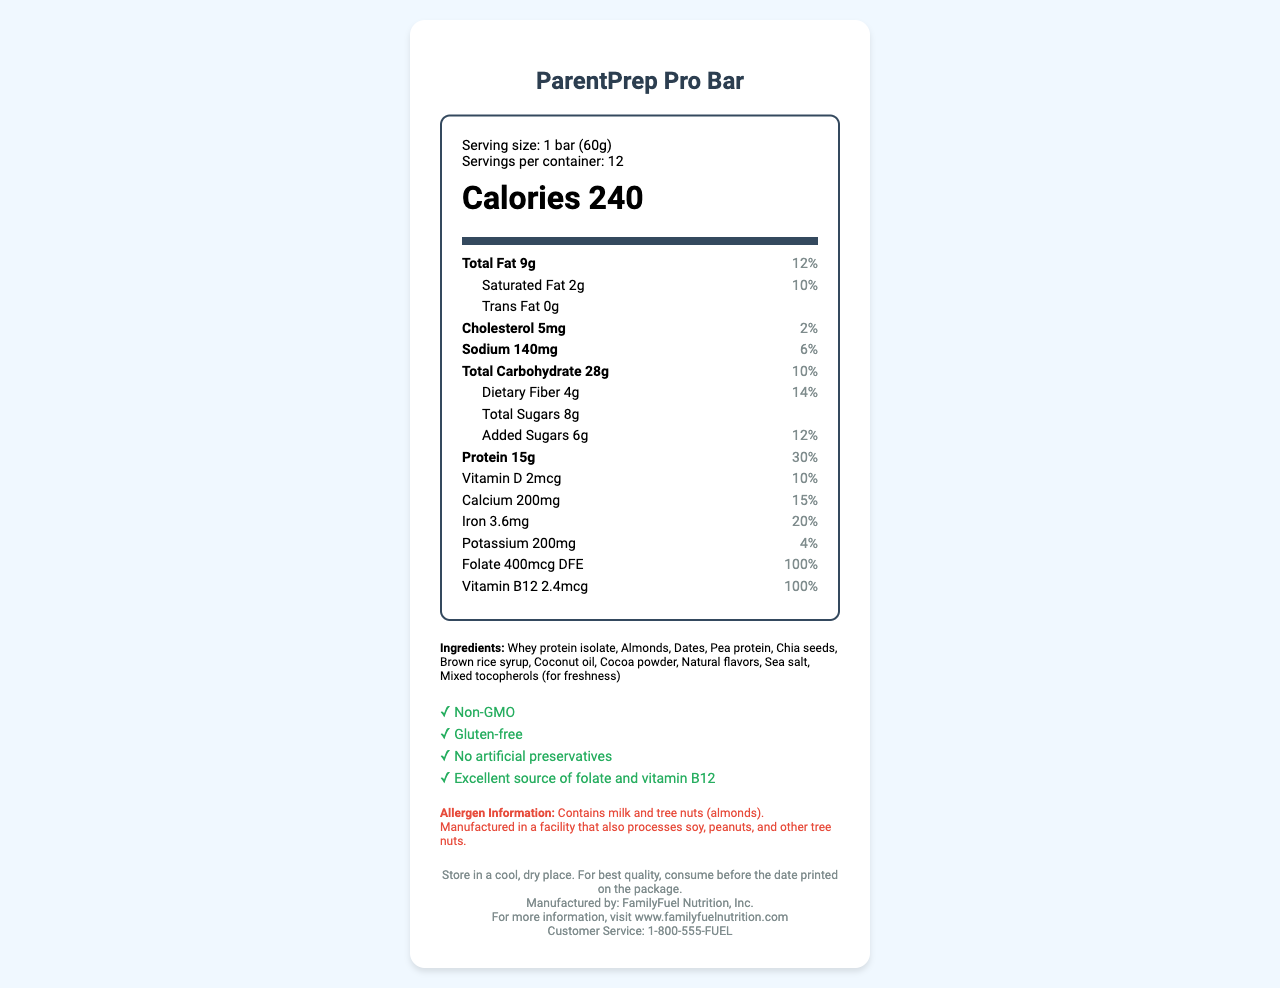What is the serving size of the ParentPrep Pro Bar? The serving size is clearly specified under the "Serving size" section of the Nutrition Facts label.
Answer: 1 bar (60g) How many calories are in one serving of the ParentPrep Pro Bar? The calorie content per serving is displayed prominently in the "Calories" section of the Nutrition Facts label.
Answer: 240 What percentage of the daily value for protein does one serving of the ParentPrep Pro Bar provide? The percentage daily value for protein is listed next to the protein amount in the Nutrition Facts label.
Answer: 30% Which ingredient is listed first on the ParentPrep Pro Bar’s ingredients list? The first ingredient listed in the ingredients section is whey protein isolate.
Answer: Whey protein isolate How much added sugars does one serving of the ParentPrep Pro Bar contain? The amount of added sugars is mentioned under the "Added Sugars" section on the label.
Answer: 6g Which of the following vitamins is not present in significant (DMV%) amounts in the ParentPrep Pro Bar? A. Vitamin D B. Vitamin C C. Vitamin B12 The Nutrition Facts Label does not mention Vitamin C, indicating its absence in significant amounts.
Answer: B. Vitamin C What is the total fat content per serving and its daily value percentage? A. 7g, 10% B. 9g, 12% C. 5g, 8% D. 3g, 4% The total fat content is 9g per serving with a daily value percentage of 12%, as shown in the Total Fat section.
Answer: B. 9g, 12% Is the ParentPrep Pro Bar gluten-free? Under special features, it is mentioned that the bar is gluten-free.
Answer: Yes Does the ParentPrep Pro Bar contain any nuts? The allergen information states that it contains almonds.
Answer: Yes Summarize the key nutritional benefits of the ParentPrep Pro Bar. The ParentPrep Pro Bar offers a balanced nutritional profile with high protein content and essential vitamins and minerals, suitable for those planning parenthood.
Answer: The ParentPrep Pro Bar is a convenient, protein-rich snack designed for busy professionals planning parenthood. It provides 15g of protein per bar, significant amounts of folate and vitamin B12, and essential minerals like calcium and iron. Additionally, it is non-GMO, gluten-free, and free from artificial preservatives. How much potassium does one bar provide? The potassium content per bar is listed in the Nutrition Facts under the "Potassium" section.
Answer: 200mg What storage instructions are provided for the ParentPrep Pro Bar? The storage instructions mentioned at the bottom of the label advise storing the bar in a cool, dry place and consuming it before the printed date for best quality.
Answer: Store in a cool, dry place. For best quality, consume before the date printed on the package. What is the daily value percentage for calcium provided by one serving of the ParentPrep Pro Bar? A. 10% B. 15% C. 20% D. 25% The daily value percentage for calcium is 15%, as indicated on the label.
Answer: B. 15% What is the amount of saturated fat in one serving of the ParentPrep Pro Bar? The amount of saturated fat is specified as 2g in the Saturated Fat section of the label.
Answer: 2g Which company manufactures the ParentPrep Pro Bar? The manufacturer's name is mentioned at the bottom of the label.
Answer: FamilyFuel Nutrition, Inc. What is the main purpose of the tocopherols included in the ParentPrep Pro Bar? Mixed tocopherols are listed with a note indicating they are included for freshness.
Answer: To maintain freshness 